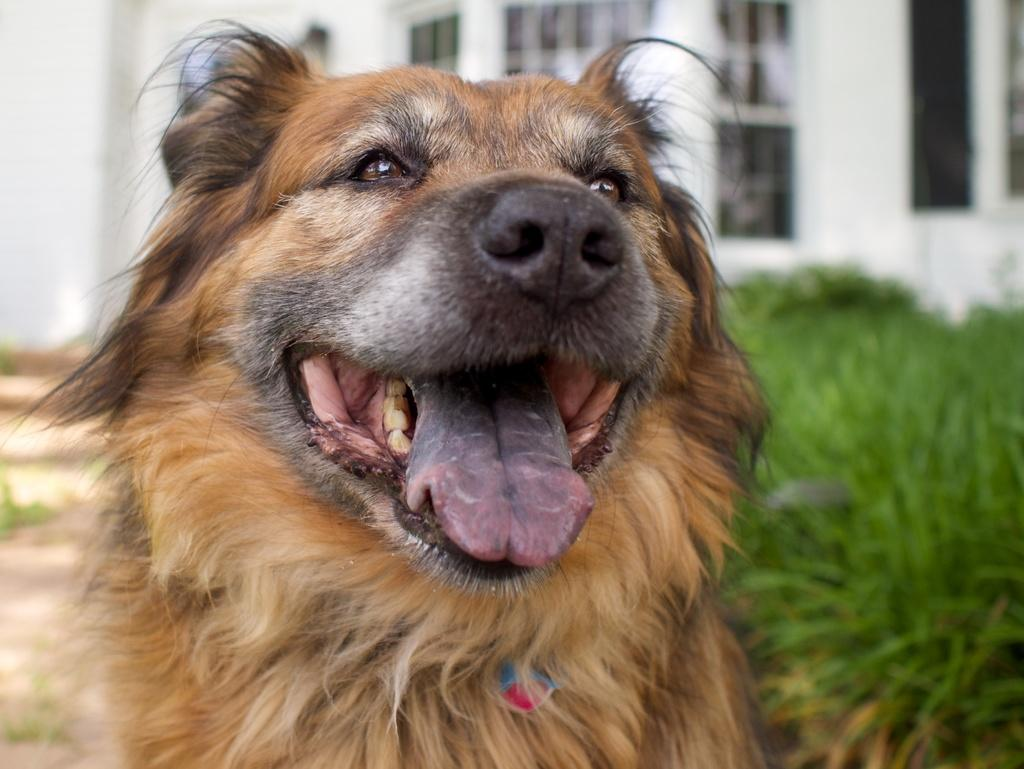What type of animal is in the image? There is a dog in the image. Can you describe the dog's appearance? The dog is brown and black in color. What else can be seen in the image besides the dog? There are plants and a building in the image. How would you describe the building's color? The building is white in color. How many rabbits are holding a basket in the image? There are no rabbits or baskets present in the image. 